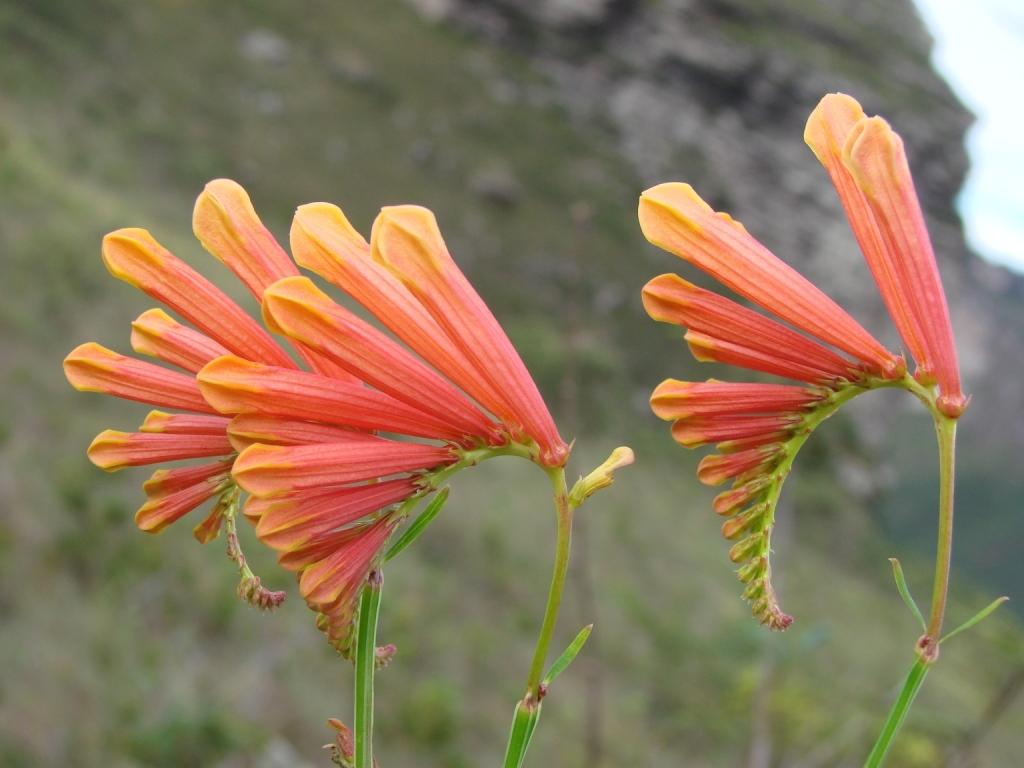What type of living organisms can be seen in the image? There are flowers in the image. Can you describe the background of the image? The background of the image is blurred. What type of icicle can be seen hanging from the flowers in the image? There is no icicle present in the image; it features flowers with a blurred background. 